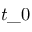Convert formula to latex. <formula><loc_0><loc_0><loc_500><loc_500>t \_ 0</formula> 